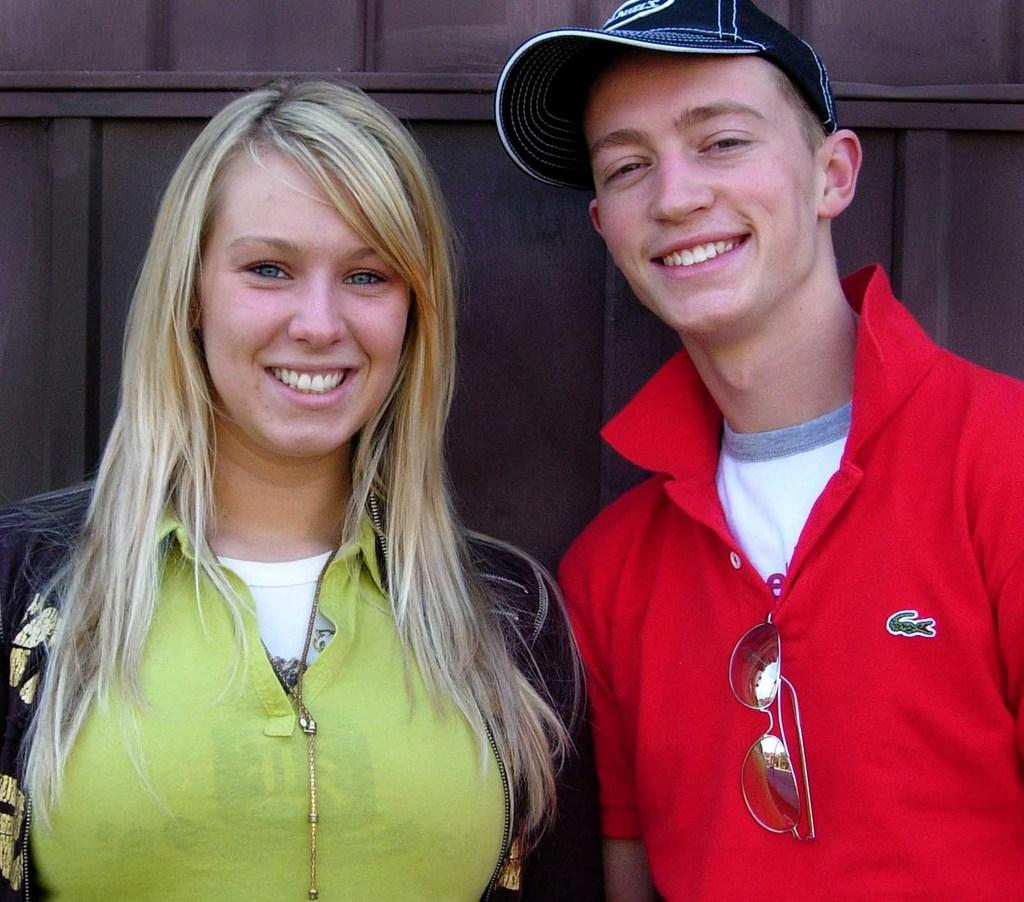How many people are in the image? There are two people in the image. What are the people doing in the image? Both people are smiling in the image. What position are the people in? The people are standing in the image. Can you describe the clothing of one of the people? One of the people is wearing a cap. What can be seen in the background of the image? There is a wall in the background of the image. What type of birth is being celebrated in the image? There is no indication of a birth or celebration in the image; it simply shows two people standing and smiling. Can you see a chain connecting the two people in the image? No, there is no chain connecting the two people in the image. 